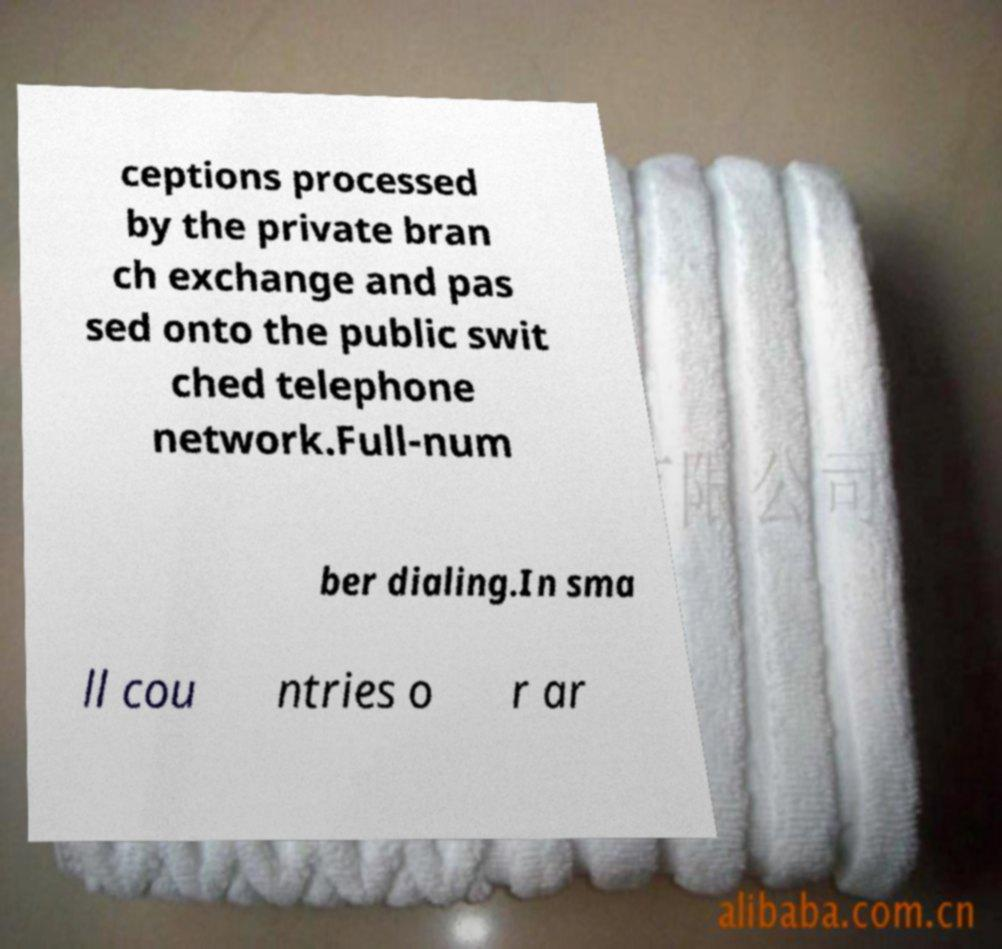Could you assist in decoding the text presented in this image and type it out clearly? ceptions processed by the private bran ch exchange and pas sed onto the public swit ched telephone network.Full-num ber dialing.In sma ll cou ntries o r ar 